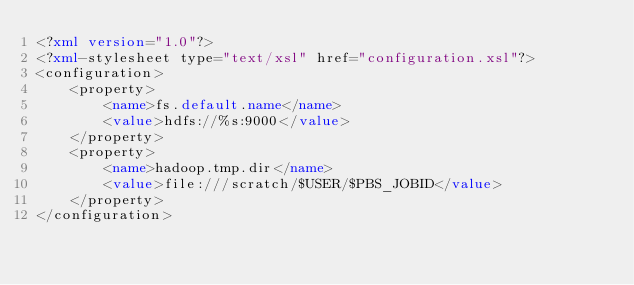<code> <loc_0><loc_0><loc_500><loc_500><_XML_><?xml version="1.0"?>
<?xml-stylesheet type="text/xsl" href="configuration.xsl"?>
<configuration>
    <property>
        <name>fs.default.name</name>
        <value>hdfs://%s:9000</value>
    </property>
    <property>
        <name>hadoop.tmp.dir</name>
        <value>file:///scratch/$USER/$PBS_JOBID</value>
    </property>
</configuration></code> 